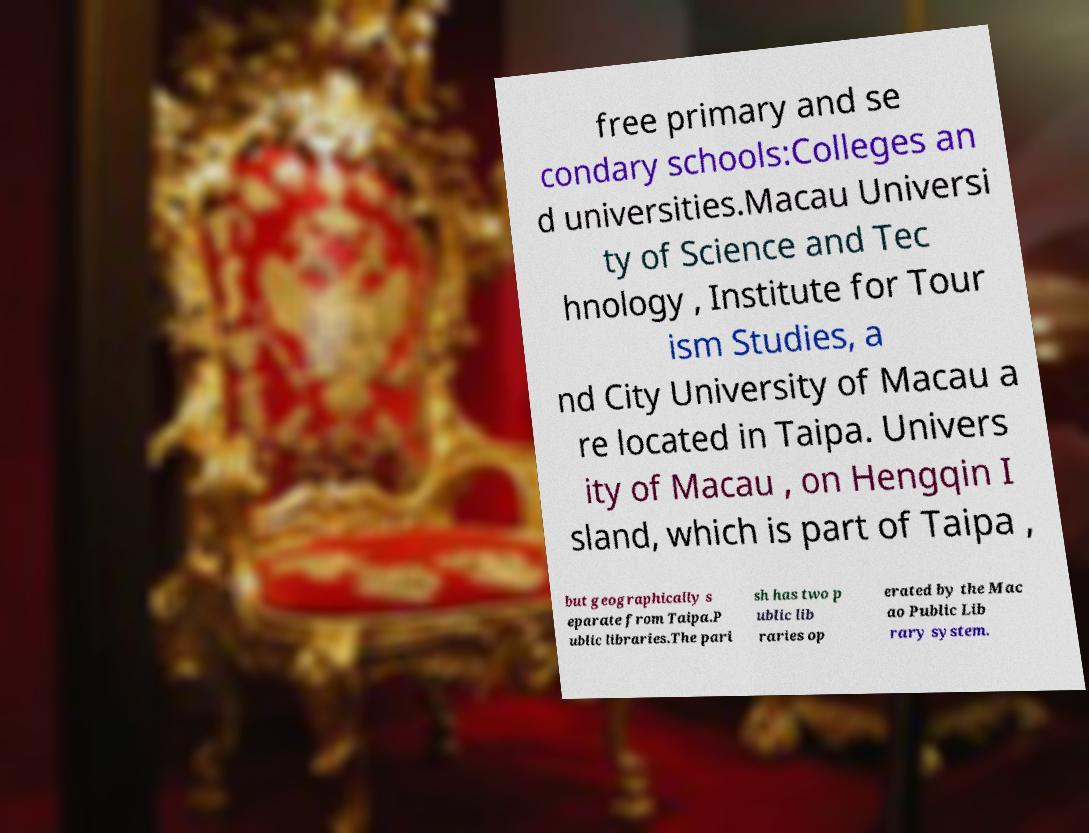Can you accurately transcribe the text from the provided image for me? free primary and se condary schools:Colleges an d universities.Macau Universi ty of Science and Tec hnology , Institute for Tour ism Studies, a nd City University of Macau a re located in Taipa. Univers ity of Macau , on Hengqin I sland, which is part of Taipa , but geographically s eparate from Taipa.P ublic libraries.The pari sh has two p ublic lib raries op erated by the Mac ao Public Lib rary system. 